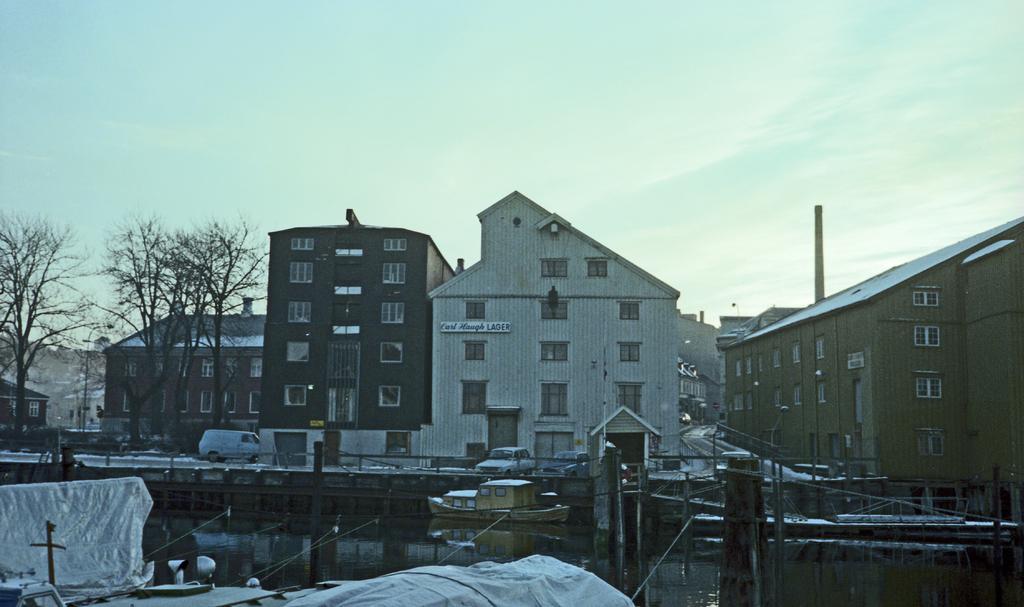How would you summarize this image in a sentence or two? In this image, we can see some buildings which are present and in-front of the buildings there are some cars which are parked and there are also some trees which are beside the buildings and in-front of the buildings there is a bridge, where there is a ship floating in the water. 